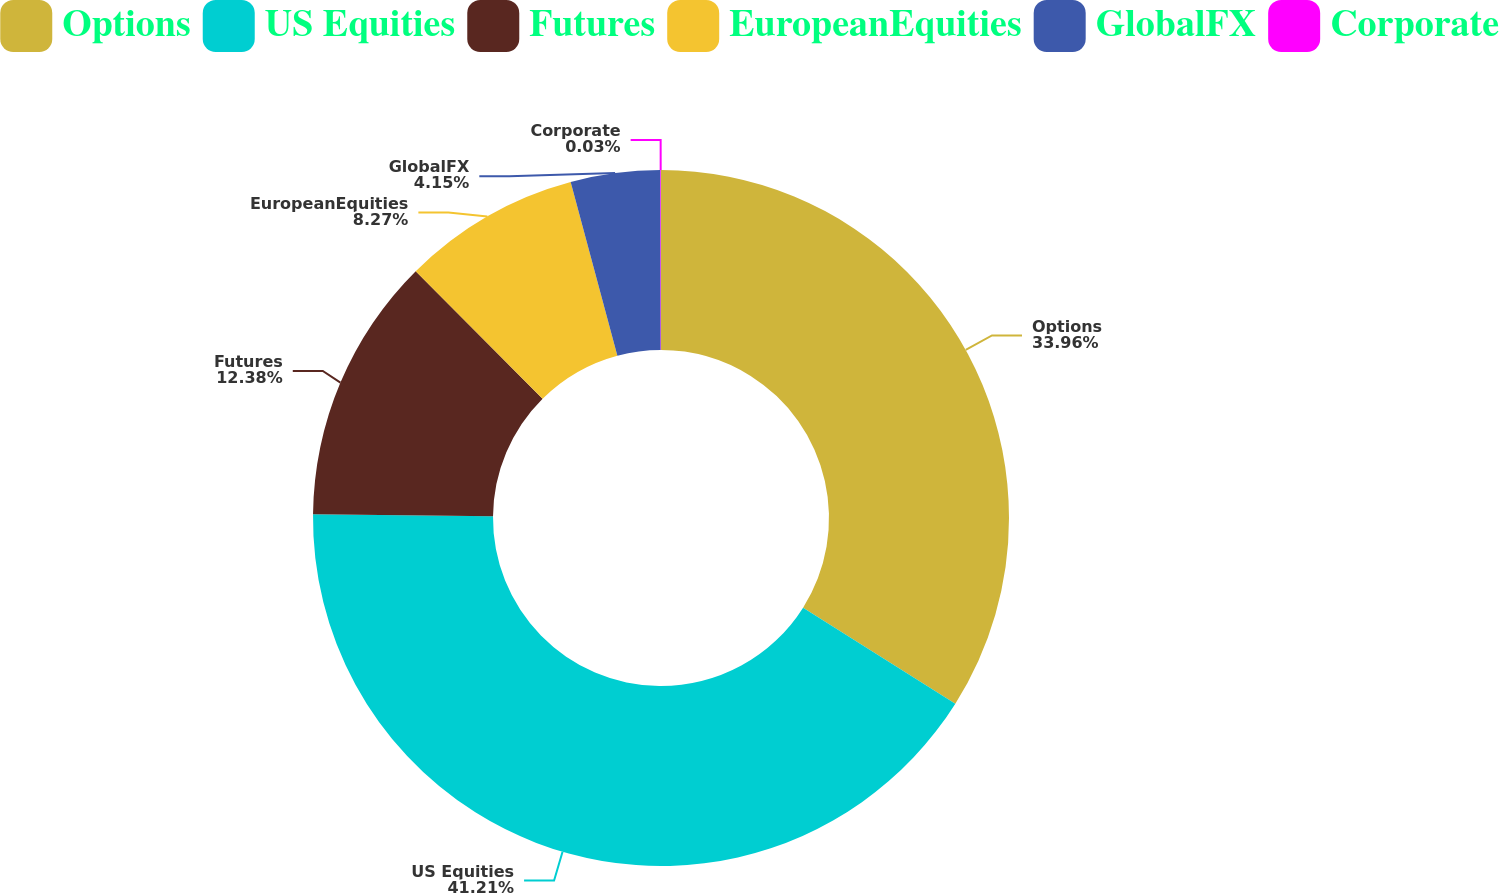Convert chart. <chart><loc_0><loc_0><loc_500><loc_500><pie_chart><fcel>Options<fcel>US Equities<fcel>Futures<fcel>EuropeanEquities<fcel>GlobalFX<fcel>Corporate<nl><fcel>33.96%<fcel>41.22%<fcel>12.38%<fcel>8.27%<fcel>4.15%<fcel>0.03%<nl></chart> 